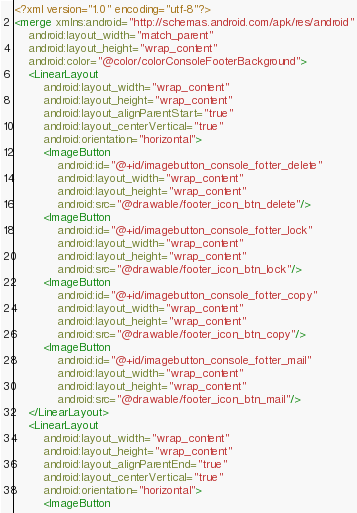Convert code to text. <code><loc_0><loc_0><loc_500><loc_500><_XML_><?xml version="1.0" encoding="utf-8"?>
<merge xmlns:android="http://schemas.android.com/apk/res/android"
    android:layout_width="match_parent"
    android:layout_height="wrap_content"
    android:color="@color/colorConsoleFooterBackground">
    <LinearLayout
        android:layout_width="wrap_content"
        android:layout_height="wrap_content"
        android:layout_alignParentStart="true"
        android:layout_centerVertical="true"
        android:orientation="horizontal">
        <ImageButton
            android:id="@+id/imagebutton_console_fotter_delete"
            android:layout_width="wrap_content"
            android:layout_height="wrap_content"
            android:src="@drawable/footer_icon_btn_delete"/>
        <ImageButton
            android:id="@+id/imagebutton_console_fotter_lock"
            android:layout_width="wrap_content"
            android:layout_height="wrap_content"
            android:src="@drawable/footer_icon_btn_lock"/>
        <ImageButton
            android:id="@+id/imagebutton_console_fotter_copy"
            android:layout_width="wrap_content"
            android:layout_height="wrap_content"
            android:src="@drawable/footer_icon_btn_copy"/>
        <ImageButton
            android:id="@+id/imagebutton_console_fotter_mail"
            android:layout_width="wrap_content"
            android:layout_height="wrap_content"
            android:src="@drawable/footer_icon_btn_mail"/>
    </LinearLayout>
    <LinearLayout
        android:layout_width="wrap_content"
        android:layout_height="wrap_content"
        android:layout_alignParentEnd="true"
        android:layout_centerVertical="true"
        android:orientation="horizontal">
        <ImageButton</code> 